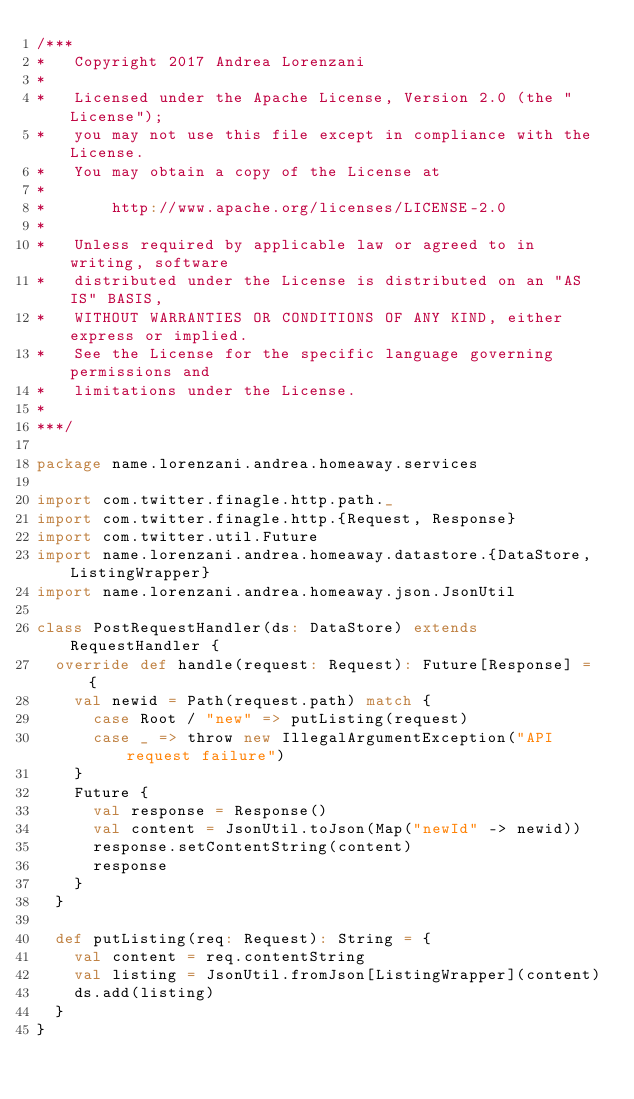<code> <loc_0><loc_0><loc_500><loc_500><_Scala_>/***
*   Copyright 2017 Andrea Lorenzani
*
*   Licensed under the Apache License, Version 2.0 (the "License");
*   you may not use this file except in compliance with the License.
*   You may obtain a copy of the License at
*
*       http://www.apache.org/licenses/LICENSE-2.0
*
*   Unless required by applicable law or agreed to in writing, software
*   distributed under the License is distributed on an "AS IS" BASIS,
*   WITHOUT WARRANTIES OR CONDITIONS OF ANY KIND, either express or implied.
*   See the License for the specific language governing permissions and
*   limitations under the License.
*
***/

package name.lorenzani.andrea.homeaway.services

import com.twitter.finagle.http.path._
import com.twitter.finagle.http.{Request, Response}
import com.twitter.util.Future
import name.lorenzani.andrea.homeaway.datastore.{DataStore, ListingWrapper}
import name.lorenzani.andrea.homeaway.json.JsonUtil

class PostRequestHandler(ds: DataStore) extends RequestHandler {
  override def handle(request: Request): Future[Response] = {
    val newid = Path(request.path) match {
      case Root / "new" => putListing(request)
      case _ => throw new IllegalArgumentException("API request failure")
    }
    Future {
      val response = Response()
      val content = JsonUtil.toJson(Map("newId" -> newid))
      response.setContentString(content)
      response
    }
  }

  def putListing(req: Request): String = {
    val content = req.contentString
    val listing = JsonUtil.fromJson[ListingWrapper](content)
    ds.add(listing)
  }
}
</code> 